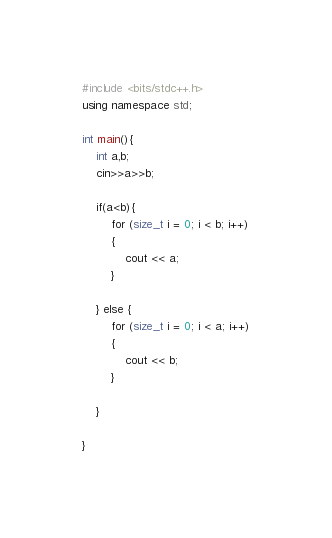Convert code to text. <code><loc_0><loc_0><loc_500><loc_500><_C++_>#include <bits/stdc++.h>
using namespace std;

int main(){
    int a,b;
    cin>>a>>b;

    if(a<b){
        for (size_t i = 0; i < b; i++)
        {
            cout << a;
        }
        
    } else {
        for (size_t i = 0; i < a; i++)
        {
            cout << b;
        }
        
    }
    
}</code> 